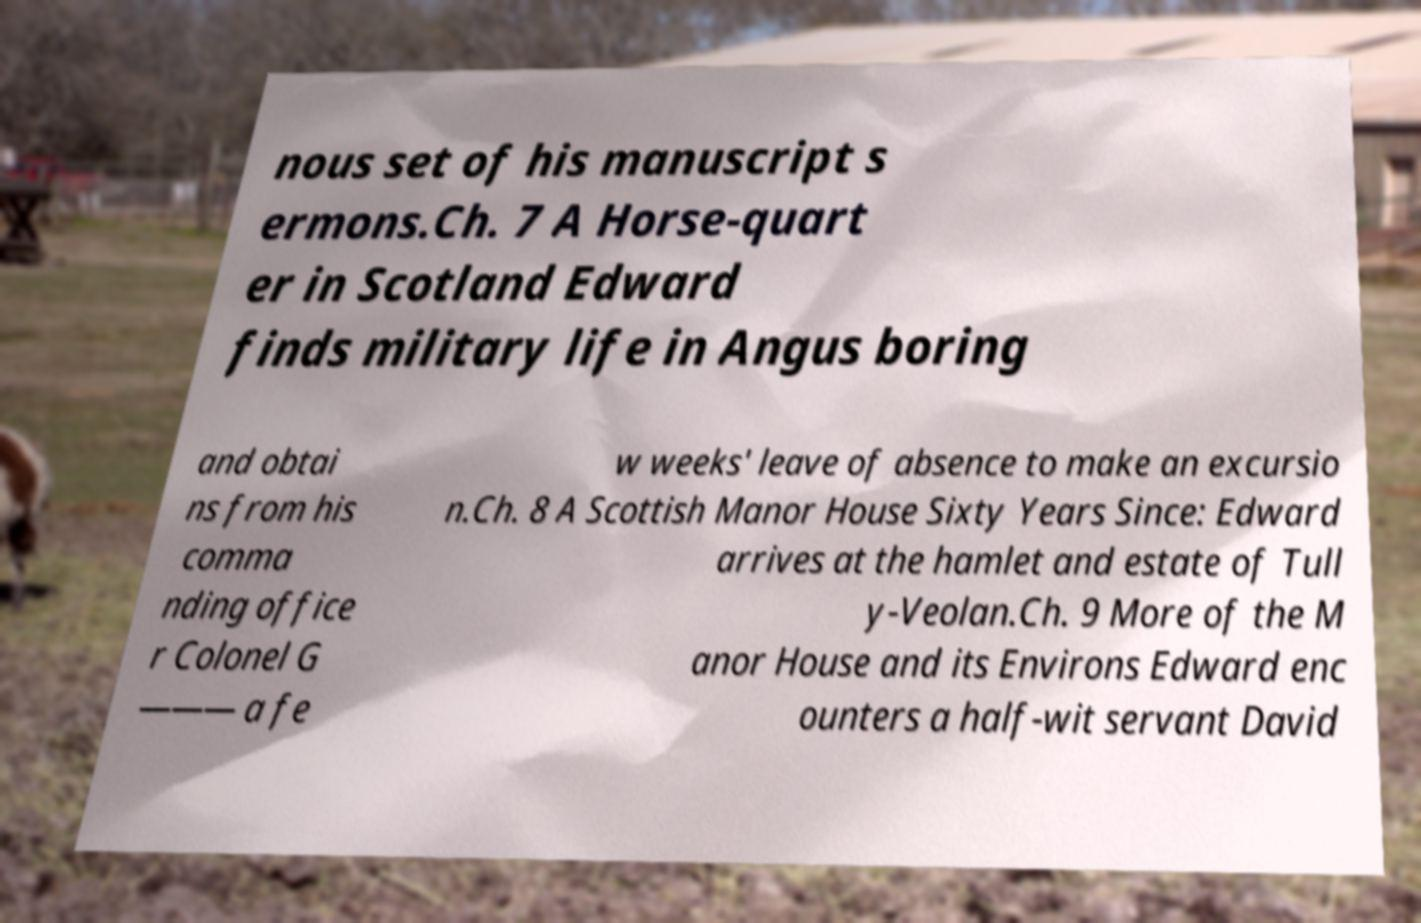I need the written content from this picture converted into text. Can you do that? nous set of his manuscript s ermons.Ch. 7 A Horse-quart er in Scotland Edward finds military life in Angus boring and obtai ns from his comma nding office r Colonel G ——— a fe w weeks' leave of absence to make an excursio n.Ch. 8 A Scottish Manor House Sixty Years Since: Edward arrives at the hamlet and estate of Tull y-Veolan.Ch. 9 More of the M anor House and its Environs Edward enc ounters a half-wit servant David 